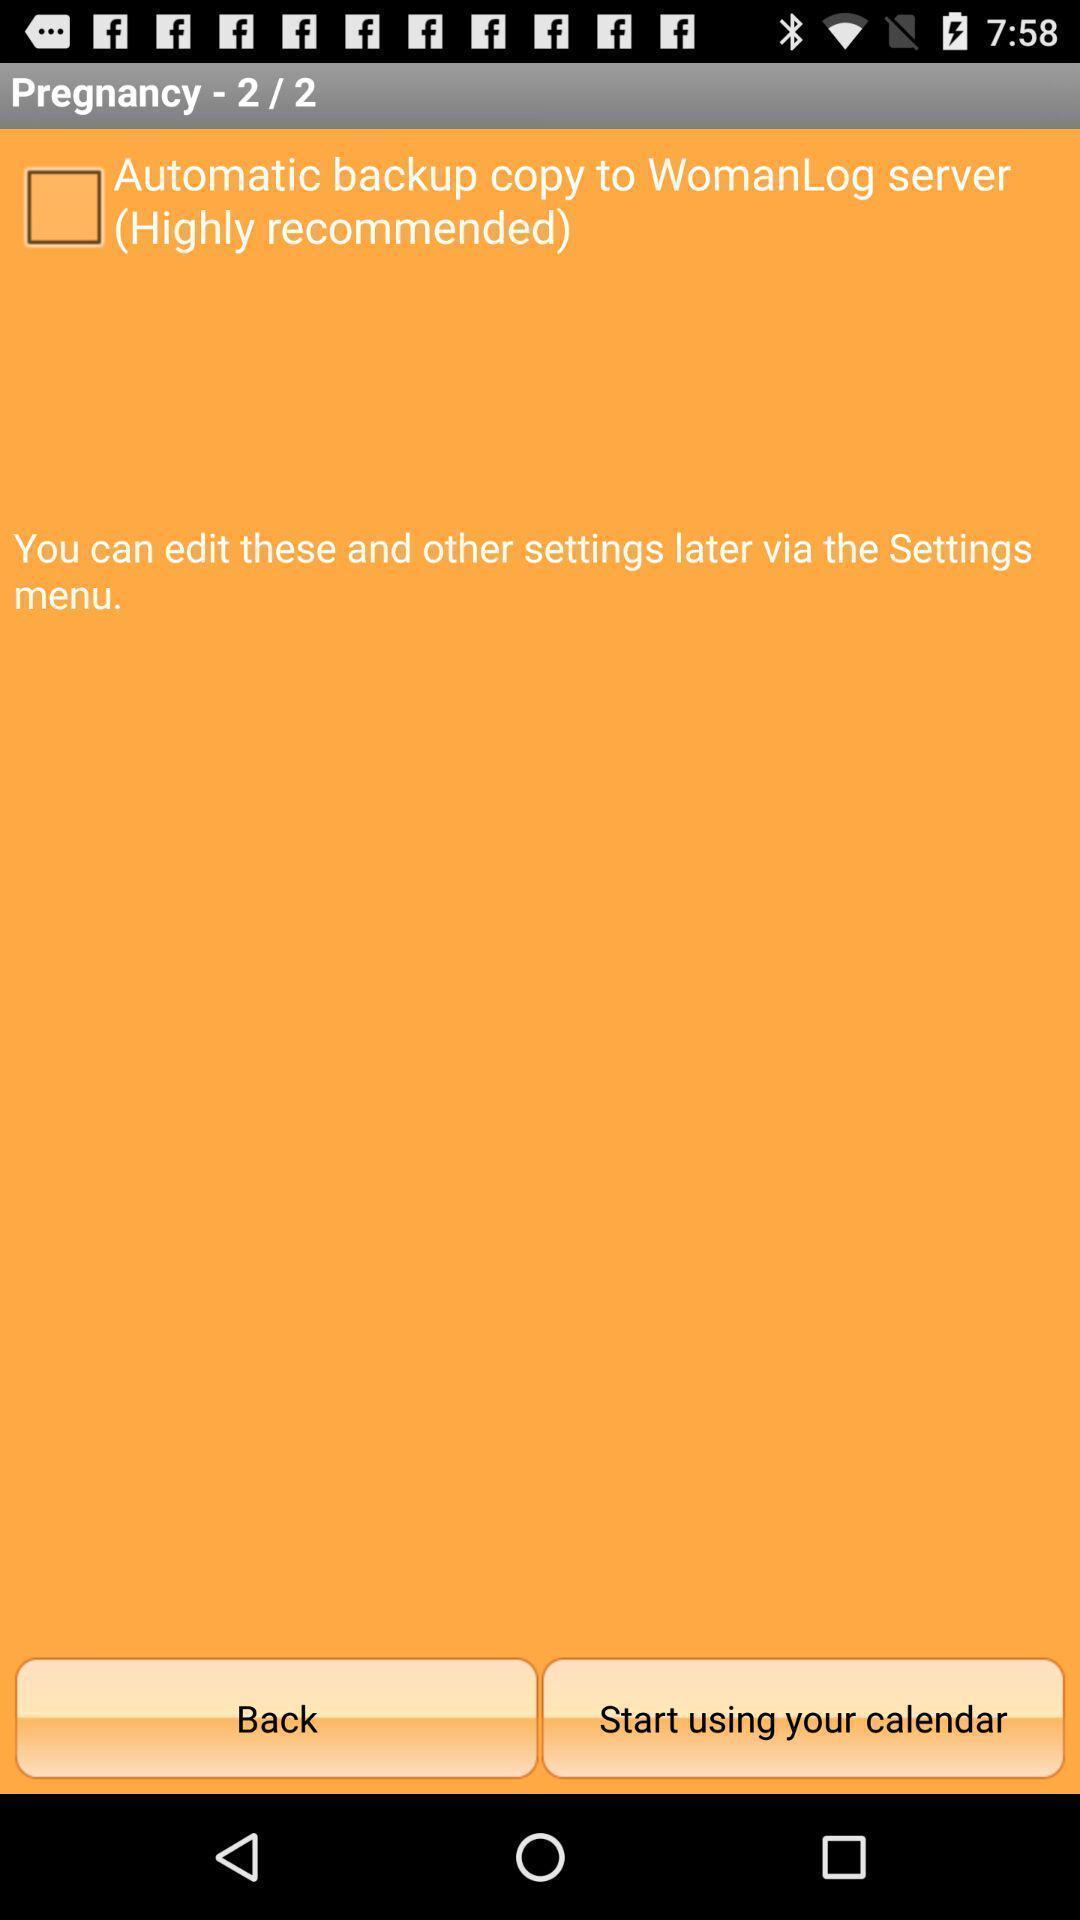What is the overall content of this screenshot? Start using your calendar option displaying in this page. 